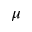<formula> <loc_0><loc_0><loc_500><loc_500>\mu</formula> 